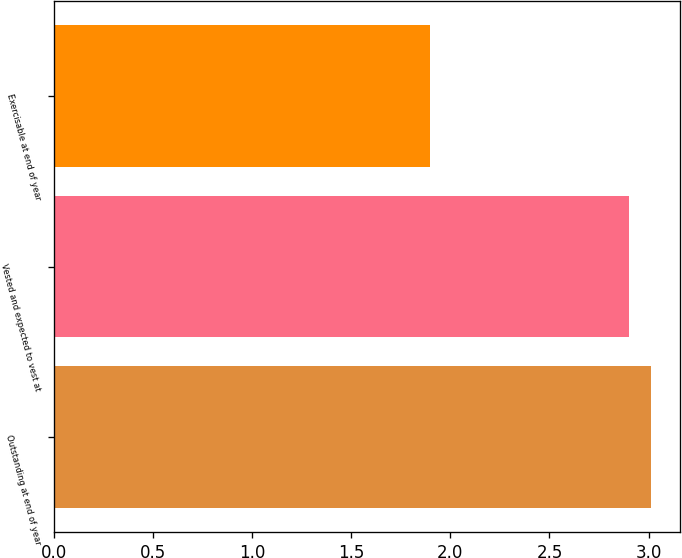<chart> <loc_0><loc_0><loc_500><loc_500><bar_chart><fcel>Outstanding at end of year<fcel>Vested and expected to vest at<fcel>Exercisable at end of year<nl><fcel>3.01<fcel>2.9<fcel>1.9<nl></chart> 